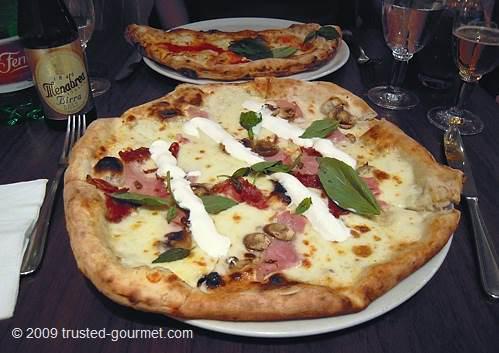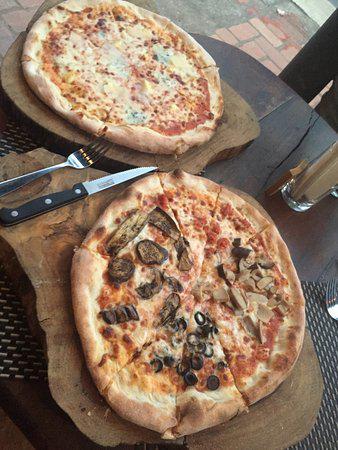The first image is the image on the left, the second image is the image on the right. For the images displayed, is the sentence "Each image contains two roundish pizzas with no slices missing." factually correct? Answer yes or no. Yes. The first image is the image on the left, the second image is the image on the right. For the images shown, is this caption "A fork and knife have been placed next to the pizza in one of the pictures." true? Answer yes or no. Yes. 